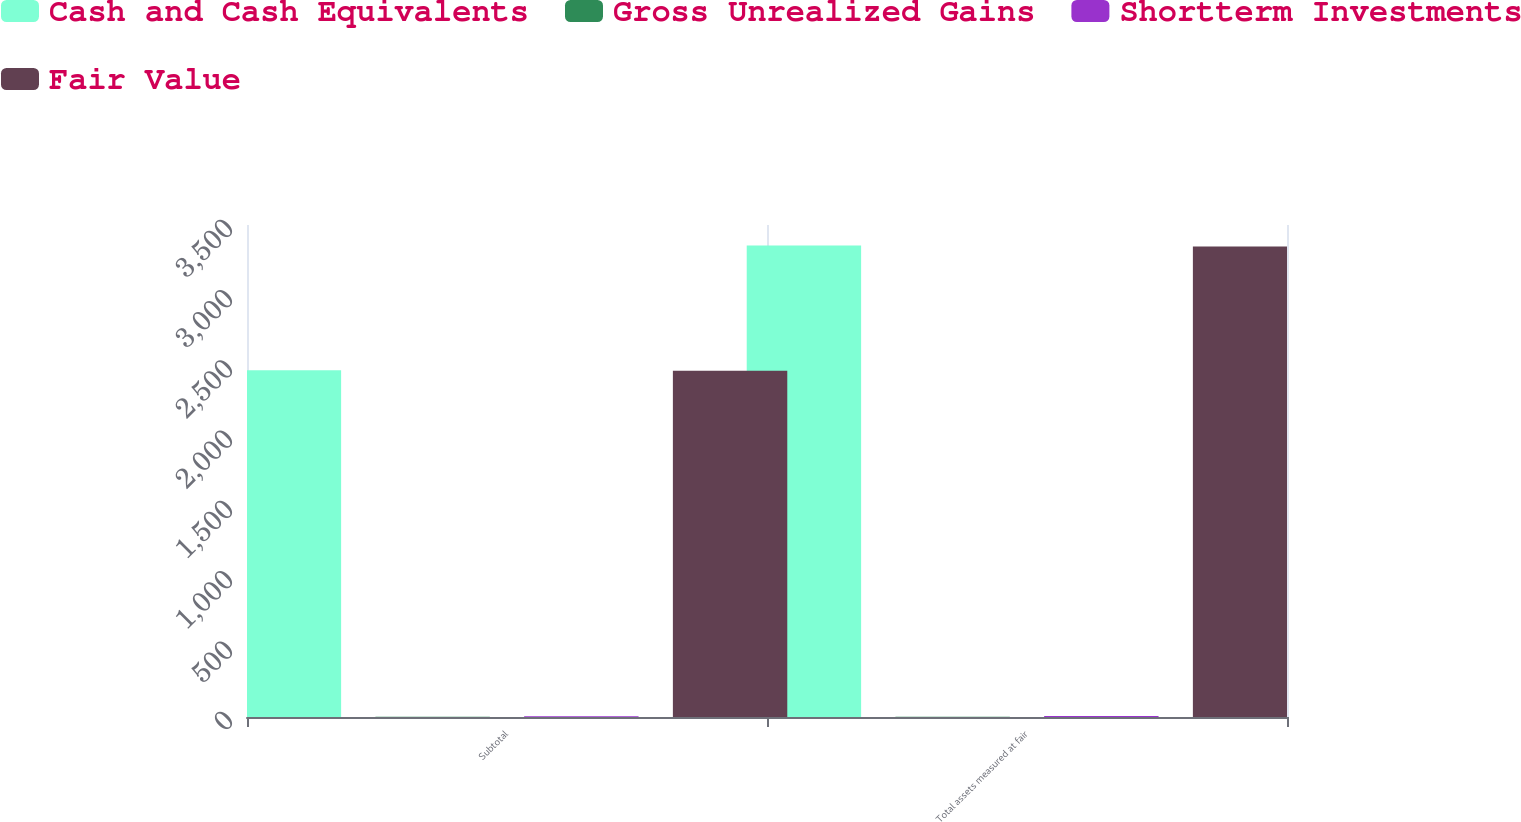<chart> <loc_0><loc_0><loc_500><loc_500><stacked_bar_chart><ecel><fcel>Subtotal<fcel>Total assets measured at fair<nl><fcel>Cash and Cash Equivalents<fcel>2466.6<fcel>3353.4<nl><fcel>Gross Unrealized Gains<fcel>1.4<fcel>1.4<nl><fcel>Shortterm Investments<fcel>5.2<fcel>7<nl><fcel>Fair Value<fcel>2462.8<fcel>3347.8<nl></chart> 